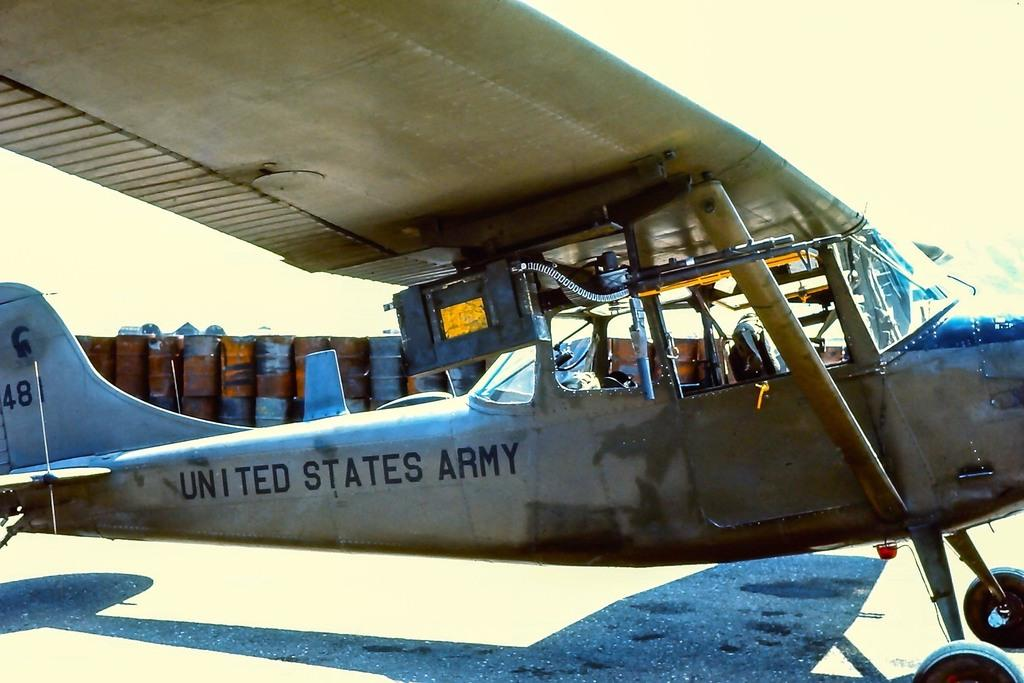What is the main subject of the image? The main subject of the image is an airplane. Where is the airplane located in the image? The airplane is on the ground in the image. What can be seen in the background of the image? There are drums in the background of the image. What type of force is being applied to the airplane in the image? There is no indication of any force being applied to the airplane in the image; it is simply on the ground. How many oranges are visible in the image? There are no oranges present in the image. 